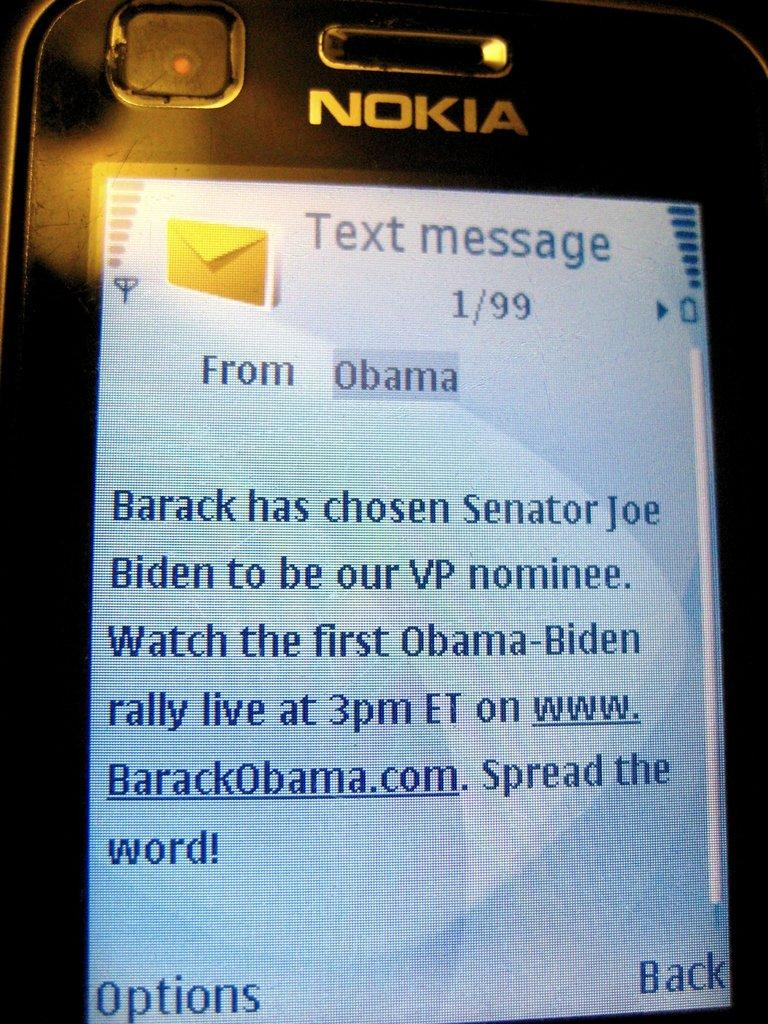<image>
Present a compact description of the photo's key features. A close up of a Nokia cell phone screen that has a text message from Obama on it. 